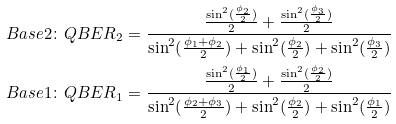Convert formula to latex. <formula><loc_0><loc_0><loc_500><loc_500>B a s e 2 \colon Q B E R _ { 2 } = \frac { \frac { \sin ^ { 2 } ( \frac { \phi _ { 2 } } { 2 } ) } { 2 } + \frac { \sin ^ { 2 } ( \frac { \phi _ { 3 } } { 2 } ) } { 2 } } { \sin ^ { 2 } ( \frac { \phi _ { 1 } + \phi _ { 2 } } { 2 } ) + \sin ^ { 2 } ( \frac { \phi _ { 2 } } { 2 } ) + \sin ^ { 2 } ( \frac { \phi _ { 3 } } { 2 } ) } \\ B a s e 1 \colon Q B E R _ { 1 } = \frac { \frac { \sin ^ { 2 } ( \frac { \phi _ { 1 } } { 2 } ) } { 2 } + \frac { \sin ^ { 2 } ( \frac { \phi _ { 2 } } { 2 } ) } { 2 } } { \sin ^ { 2 } ( \frac { \phi _ { 2 } + \phi _ { 3 } } { 2 } ) + \sin ^ { 2 } ( \frac { \phi _ { 2 } } { 2 } ) + \sin ^ { 2 } ( \frac { \phi _ { 1 } } { 2 } ) }</formula> 